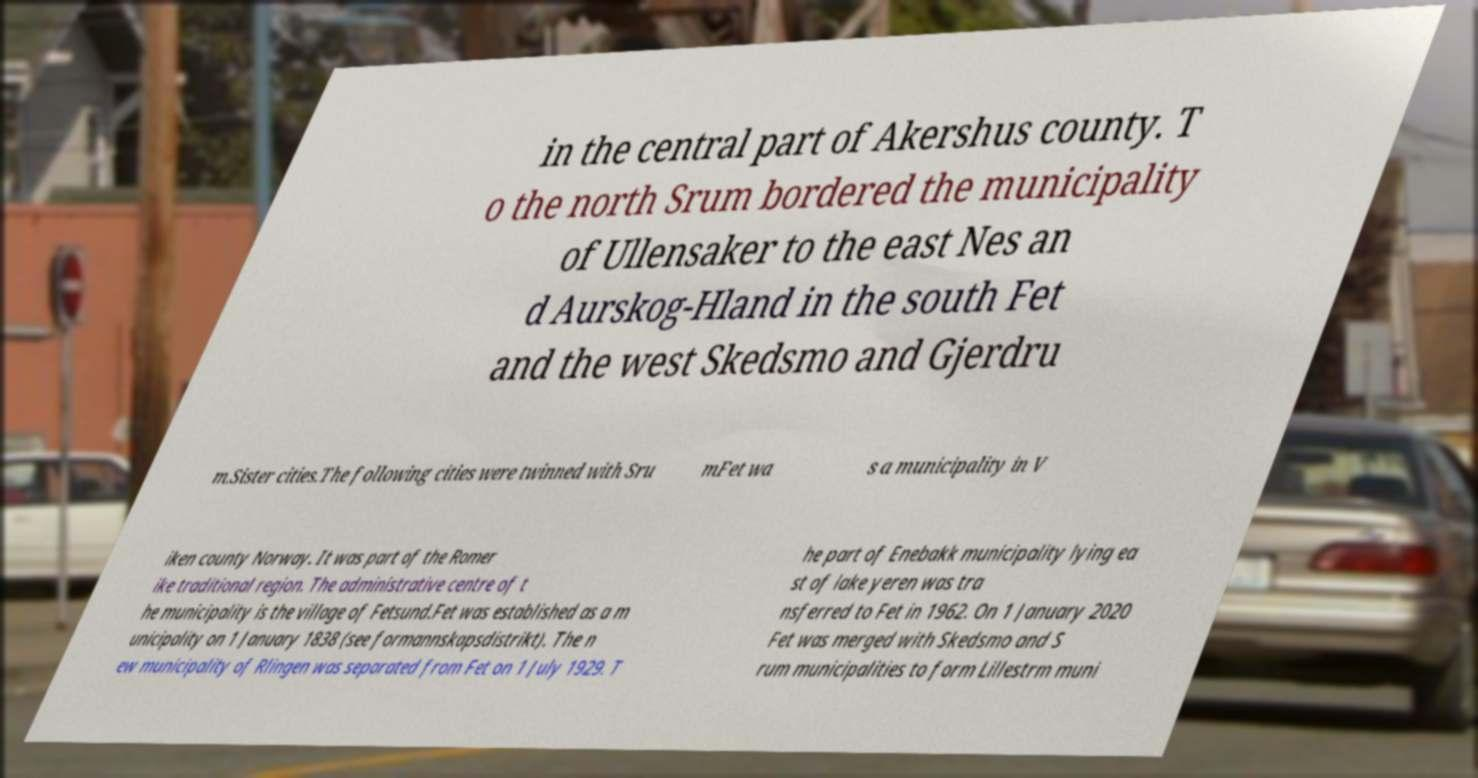Can you read and provide the text displayed in the image?This photo seems to have some interesting text. Can you extract and type it out for me? in the central part of Akershus county. T o the north Srum bordered the municipality of Ullensaker to the east Nes an d Aurskog-Hland in the south Fet and the west Skedsmo and Gjerdru m.Sister cities.The following cities were twinned with Sru mFet wa s a municipality in V iken county Norway. It was part of the Romer ike traditional region. The administrative centre of t he municipality is the village of Fetsund.Fet was established as a m unicipality on 1 January 1838 (see formannskapsdistrikt). The n ew municipality of Rlingen was separated from Fet on 1 July 1929. T he part of Enebakk municipality lying ea st of lake yeren was tra nsferred to Fet in 1962. On 1 January 2020 Fet was merged with Skedsmo and S rum municipalities to form Lillestrm muni 